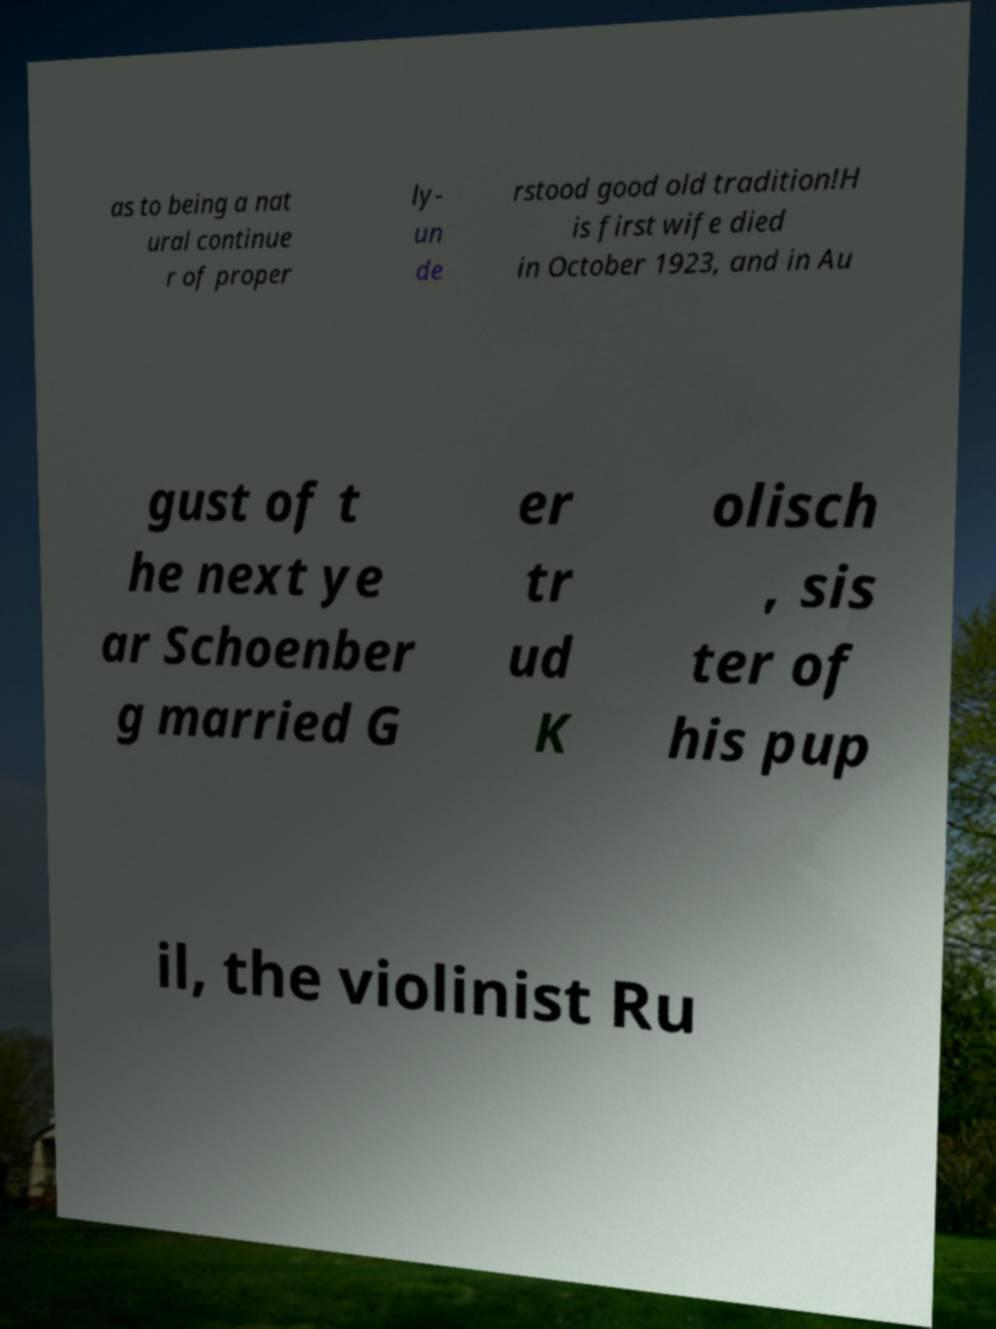Please read and relay the text visible in this image. What does it say? as to being a nat ural continue r of proper ly- un de rstood good old tradition!H is first wife died in October 1923, and in Au gust of t he next ye ar Schoenber g married G er tr ud K olisch , sis ter of his pup il, the violinist Ru 